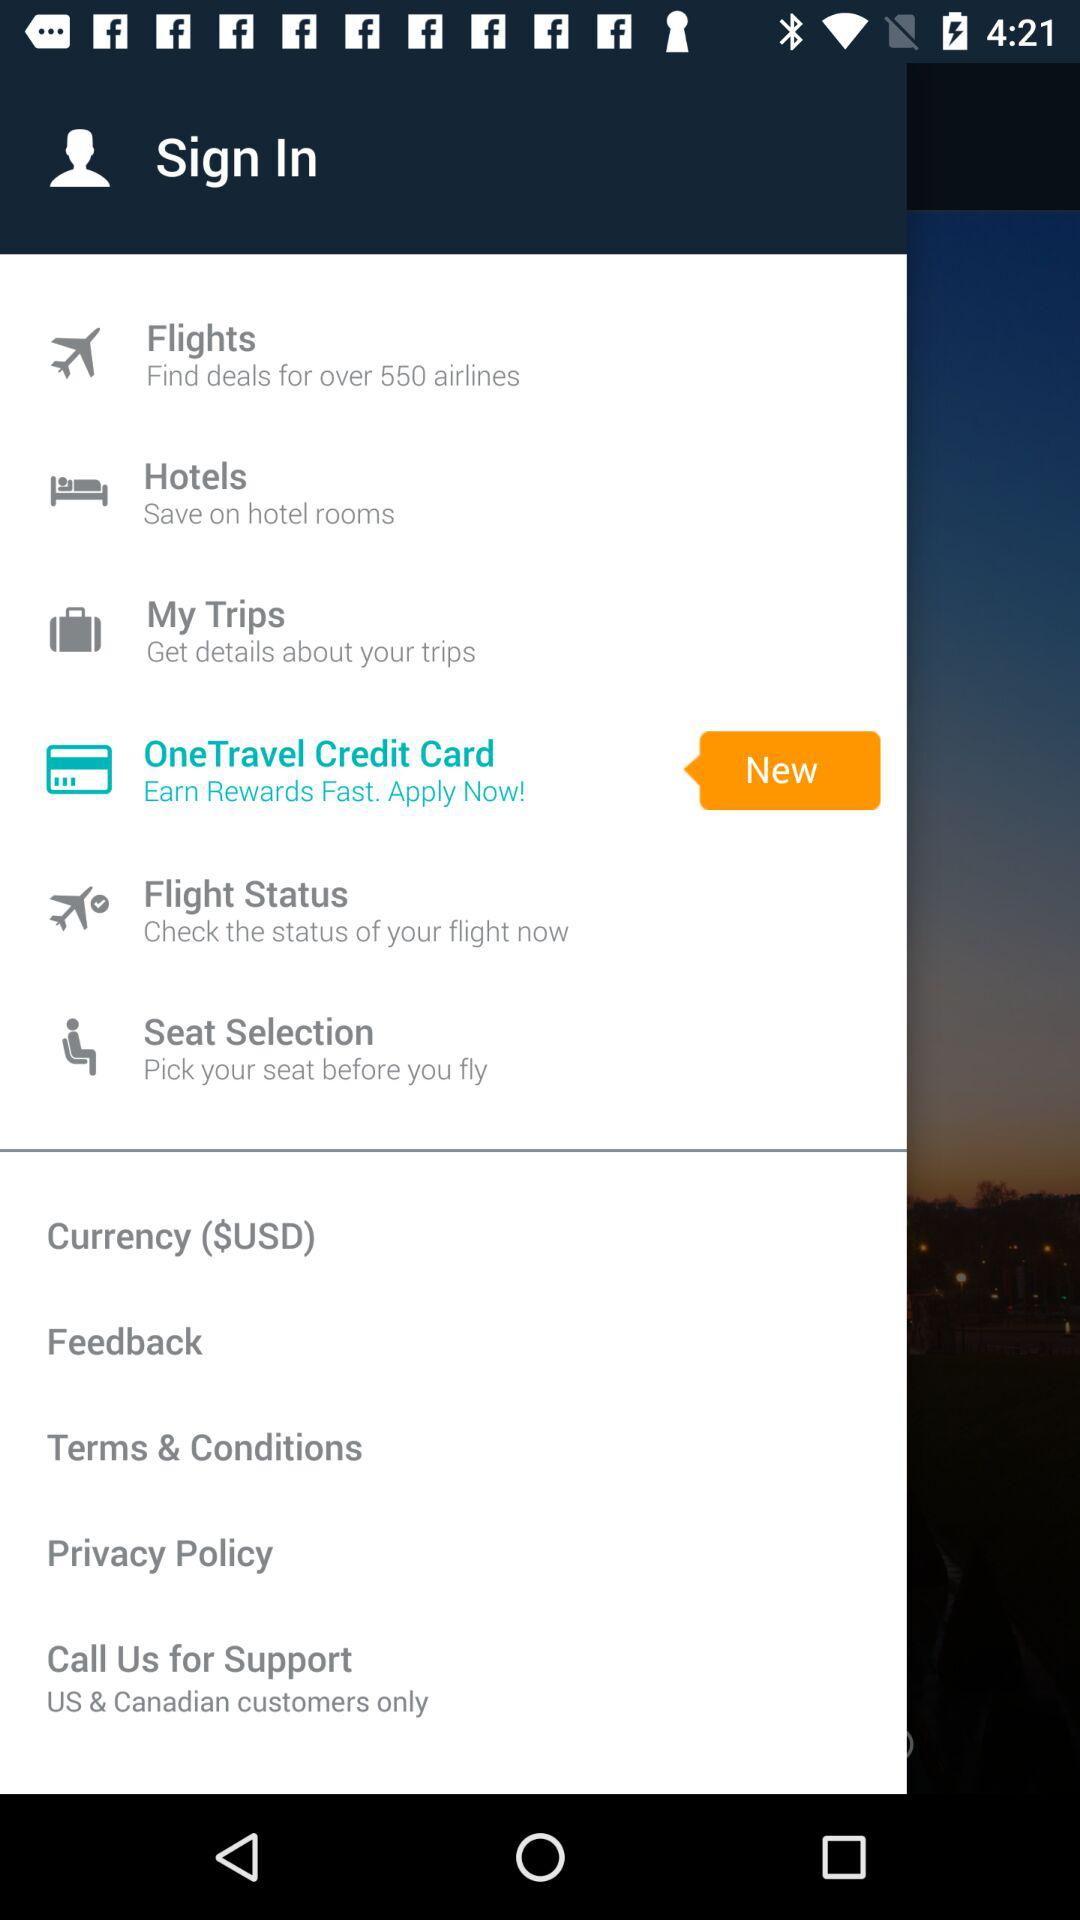What's the total number of airlines with which there are deals? The total number of airlines with which there are deals is 550. 